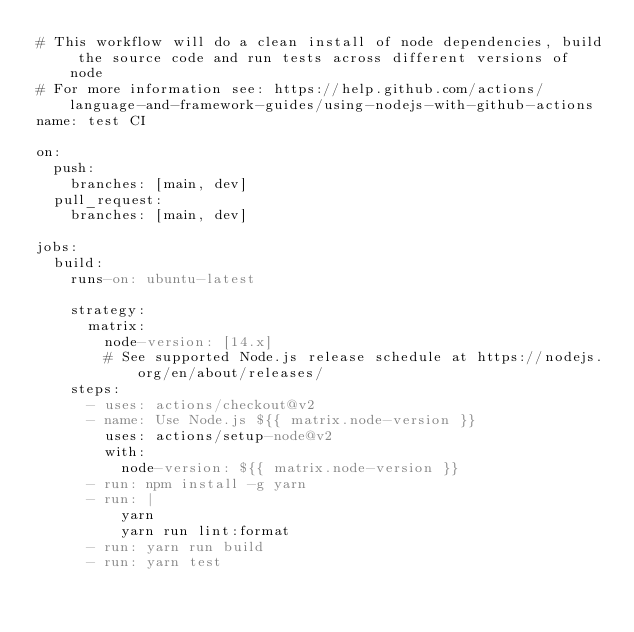Convert code to text. <code><loc_0><loc_0><loc_500><loc_500><_YAML_># This workflow will do a clean install of node dependencies, build the source code and run tests across different versions of node
# For more information see: https://help.github.com/actions/language-and-framework-guides/using-nodejs-with-github-actions
name: test CI

on:
  push:
    branches: [main, dev]
  pull_request:
    branches: [main, dev]

jobs:
  build:
    runs-on: ubuntu-latest

    strategy:
      matrix:
        node-version: [14.x]
        # See supported Node.js release schedule at https://nodejs.org/en/about/releases/
    steps:
      - uses: actions/checkout@v2
      - name: Use Node.js ${{ matrix.node-version }}
        uses: actions/setup-node@v2
        with:
          node-version: ${{ matrix.node-version }}
      - run: npm install -g yarn
      - run: |
          yarn
          yarn run lint:format
      - run: yarn run build
      - run: yarn test
</code> 